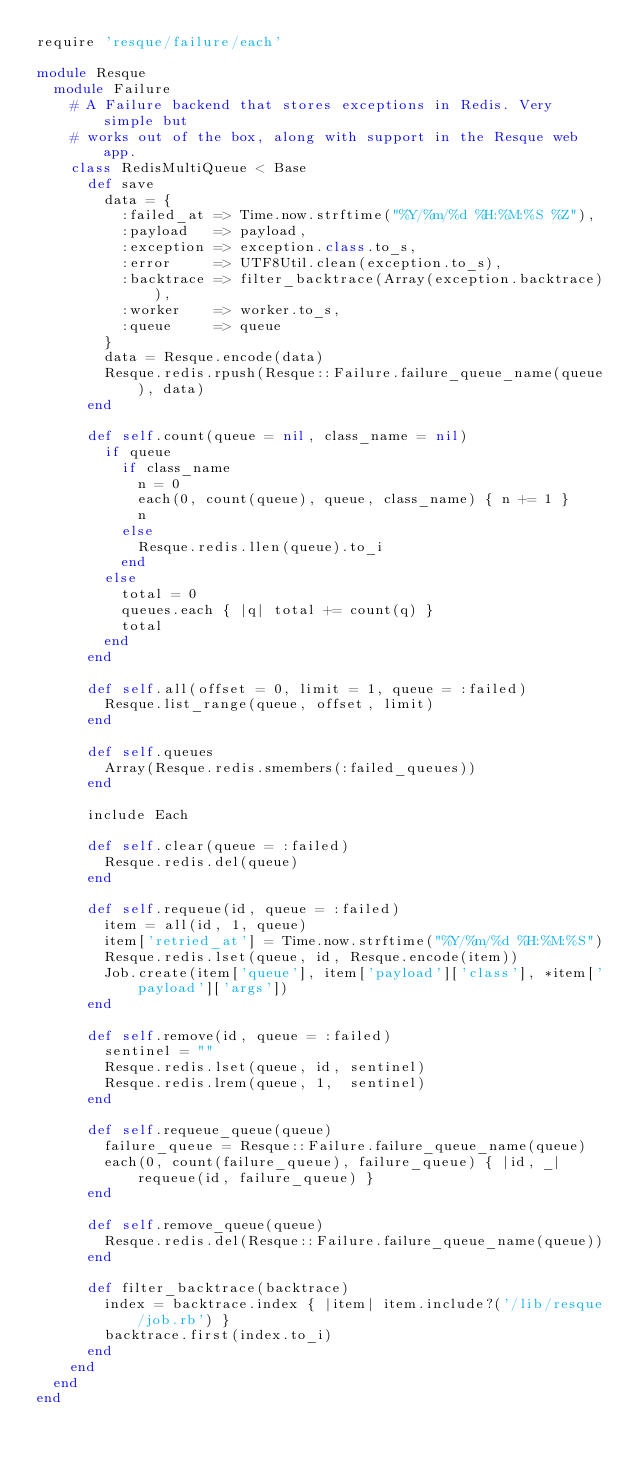Convert code to text. <code><loc_0><loc_0><loc_500><loc_500><_Ruby_>require 'resque/failure/each'

module Resque
  module Failure
    # A Failure backend that stores exceptions in Redis. Very simple but
    # works out of the box, along with support in the Resque web app.
    class RedisMultiQueue < Base
      def save
        data = {
          :failed_at => Time.now.strftime("%Y/%m/%d %H:%M:%S %Z"),
          :payload   => payload,
          :exception => exception.class.to_s,
          :error     => UTF8Util.clean(exception.to_s),
          :backtrace => filter_backtrace(Array(exception.backtrace)),
          :worker    => worker.to_s,
          :queue     => queue
        }
        data = Resque.encode(data)
        Resque.redis.rpush(Resque::Failure.failure_queue_name(queue), data)
      end

      def self.count(queue = nil, class_name = nil)
        if queue
          if class_name
            n = 0
            each(0, count(queue), queue, class_name) { n += 1 } 
            n
          else
            Resque.redis.llen(queue).to_i
          end
        else
          total = 0
          queues.each { |q| total += count(q) }
          total
        end
      end

      def self.all(offset = 0, limit = 1, queue = :failed)
        Resque.list_range(queue, offset, limit)
      end

      def self.queues
        Array(Resque.redis.smembers(:failed_queues))
      end

      include Each

      def self.clear(queue = :failed)
        Resque.redis.del(queue)
      end

      def self.requeue(id, queue = :failed)
        item = all(id, 1, queue)
        item['retried_at'] = Time.now.strftime("%Y/%m/%d %H:%M:%S")
        Resque.redis.lset(queue, id, Resque.encode(item))
        Job.create(item['queue'], item['payload']['class'], *item['payload']['args'])
      end

      def self.remove(id, queue = :failed)
        sentinel = ""
        Resque.redis.lset(queue, id, sentinel)
        Resque.redis.lrem(queue, 1,  sentinel)
      end

      def self.requeue_queue(queue)
        failure_queue = Resque::Failure.failure_queue_name(queue)
        each(0, count(failure_queue), failure_queue) { |id, _| requeue(id, failure_queue) }
      end

      def self.remove_queue(queue)
        Resque.redis.del(Resque::Failure.failure_queue_name(queue))
      end

      def filter_backtrace(backtrace)
        index = backtrace.index { |item| item.include?('/lib/resque/job.rb') }
        backtrace.first(index.to_i)
      end
    end
  end
end
</code> 